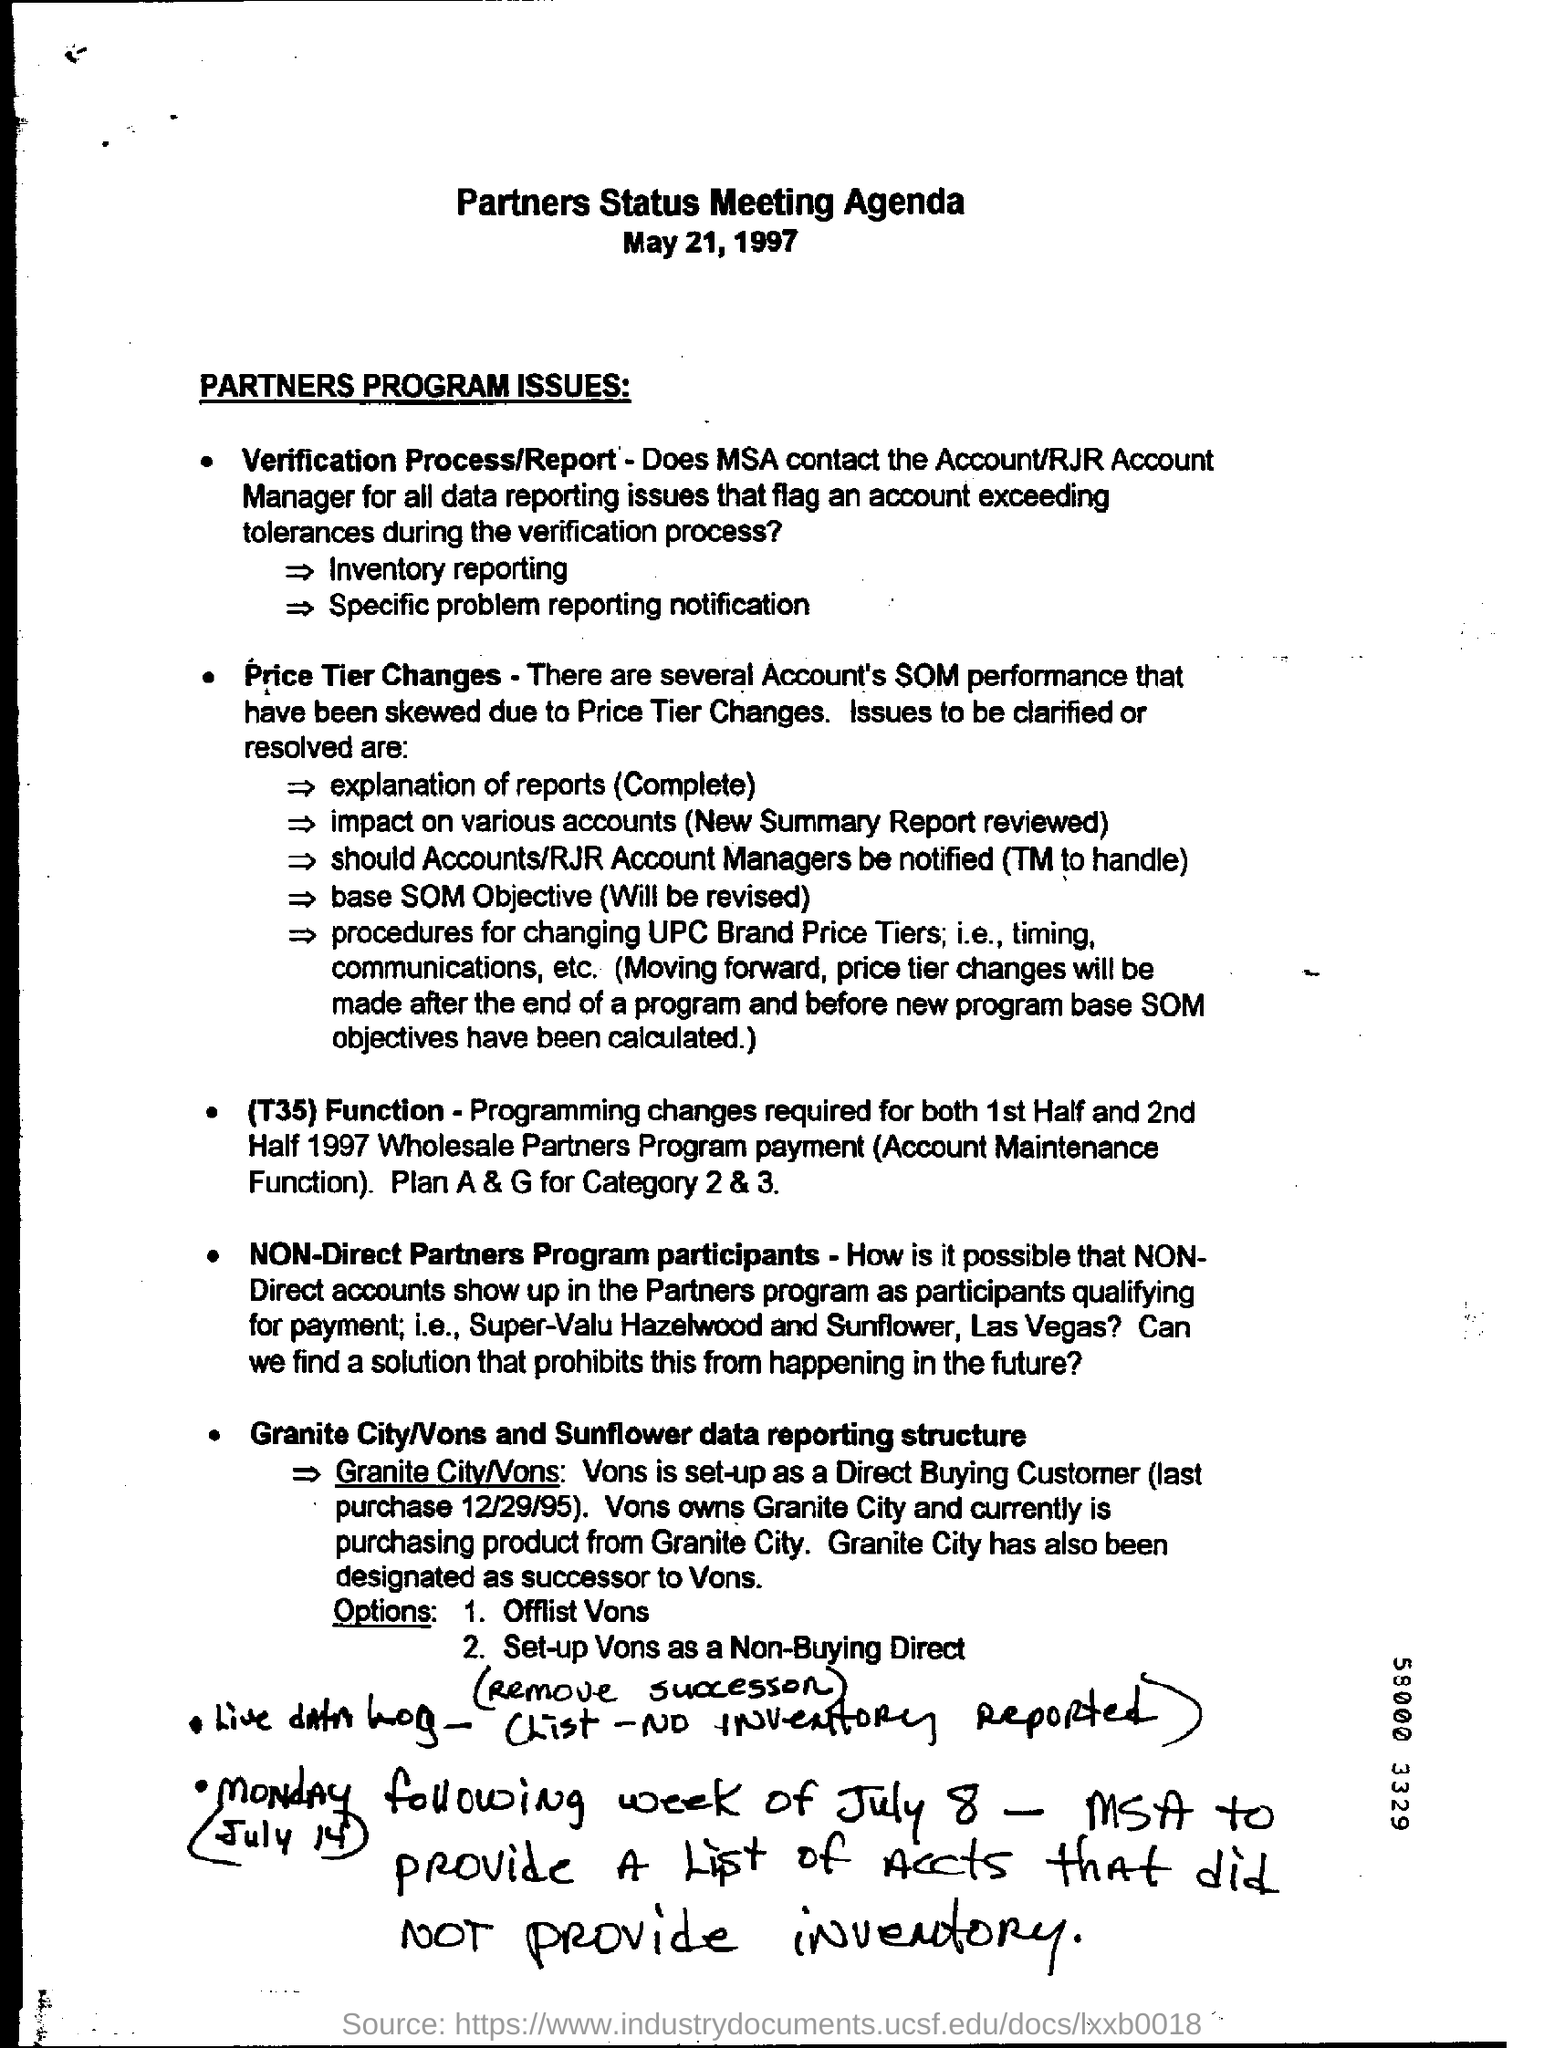When is the document dated?
Ensure brevity in your answer.  May 21, 1997. 